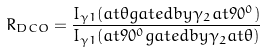Convert formula to latex. <formula><loc_0><loc_0><loc_500><loc_500>R _ { D C O } = \frac { I _ { \gamma 1 } ( a t \theta g a t e d b y \gamma _ { 2 } a t 9 0 ^ { 0 } ) } { I _ { \gamma 1 } ( a t 9 0 ^ { 0 } g a t e d b y \gamma _ { 2 } a t \theta ) }</formula> 